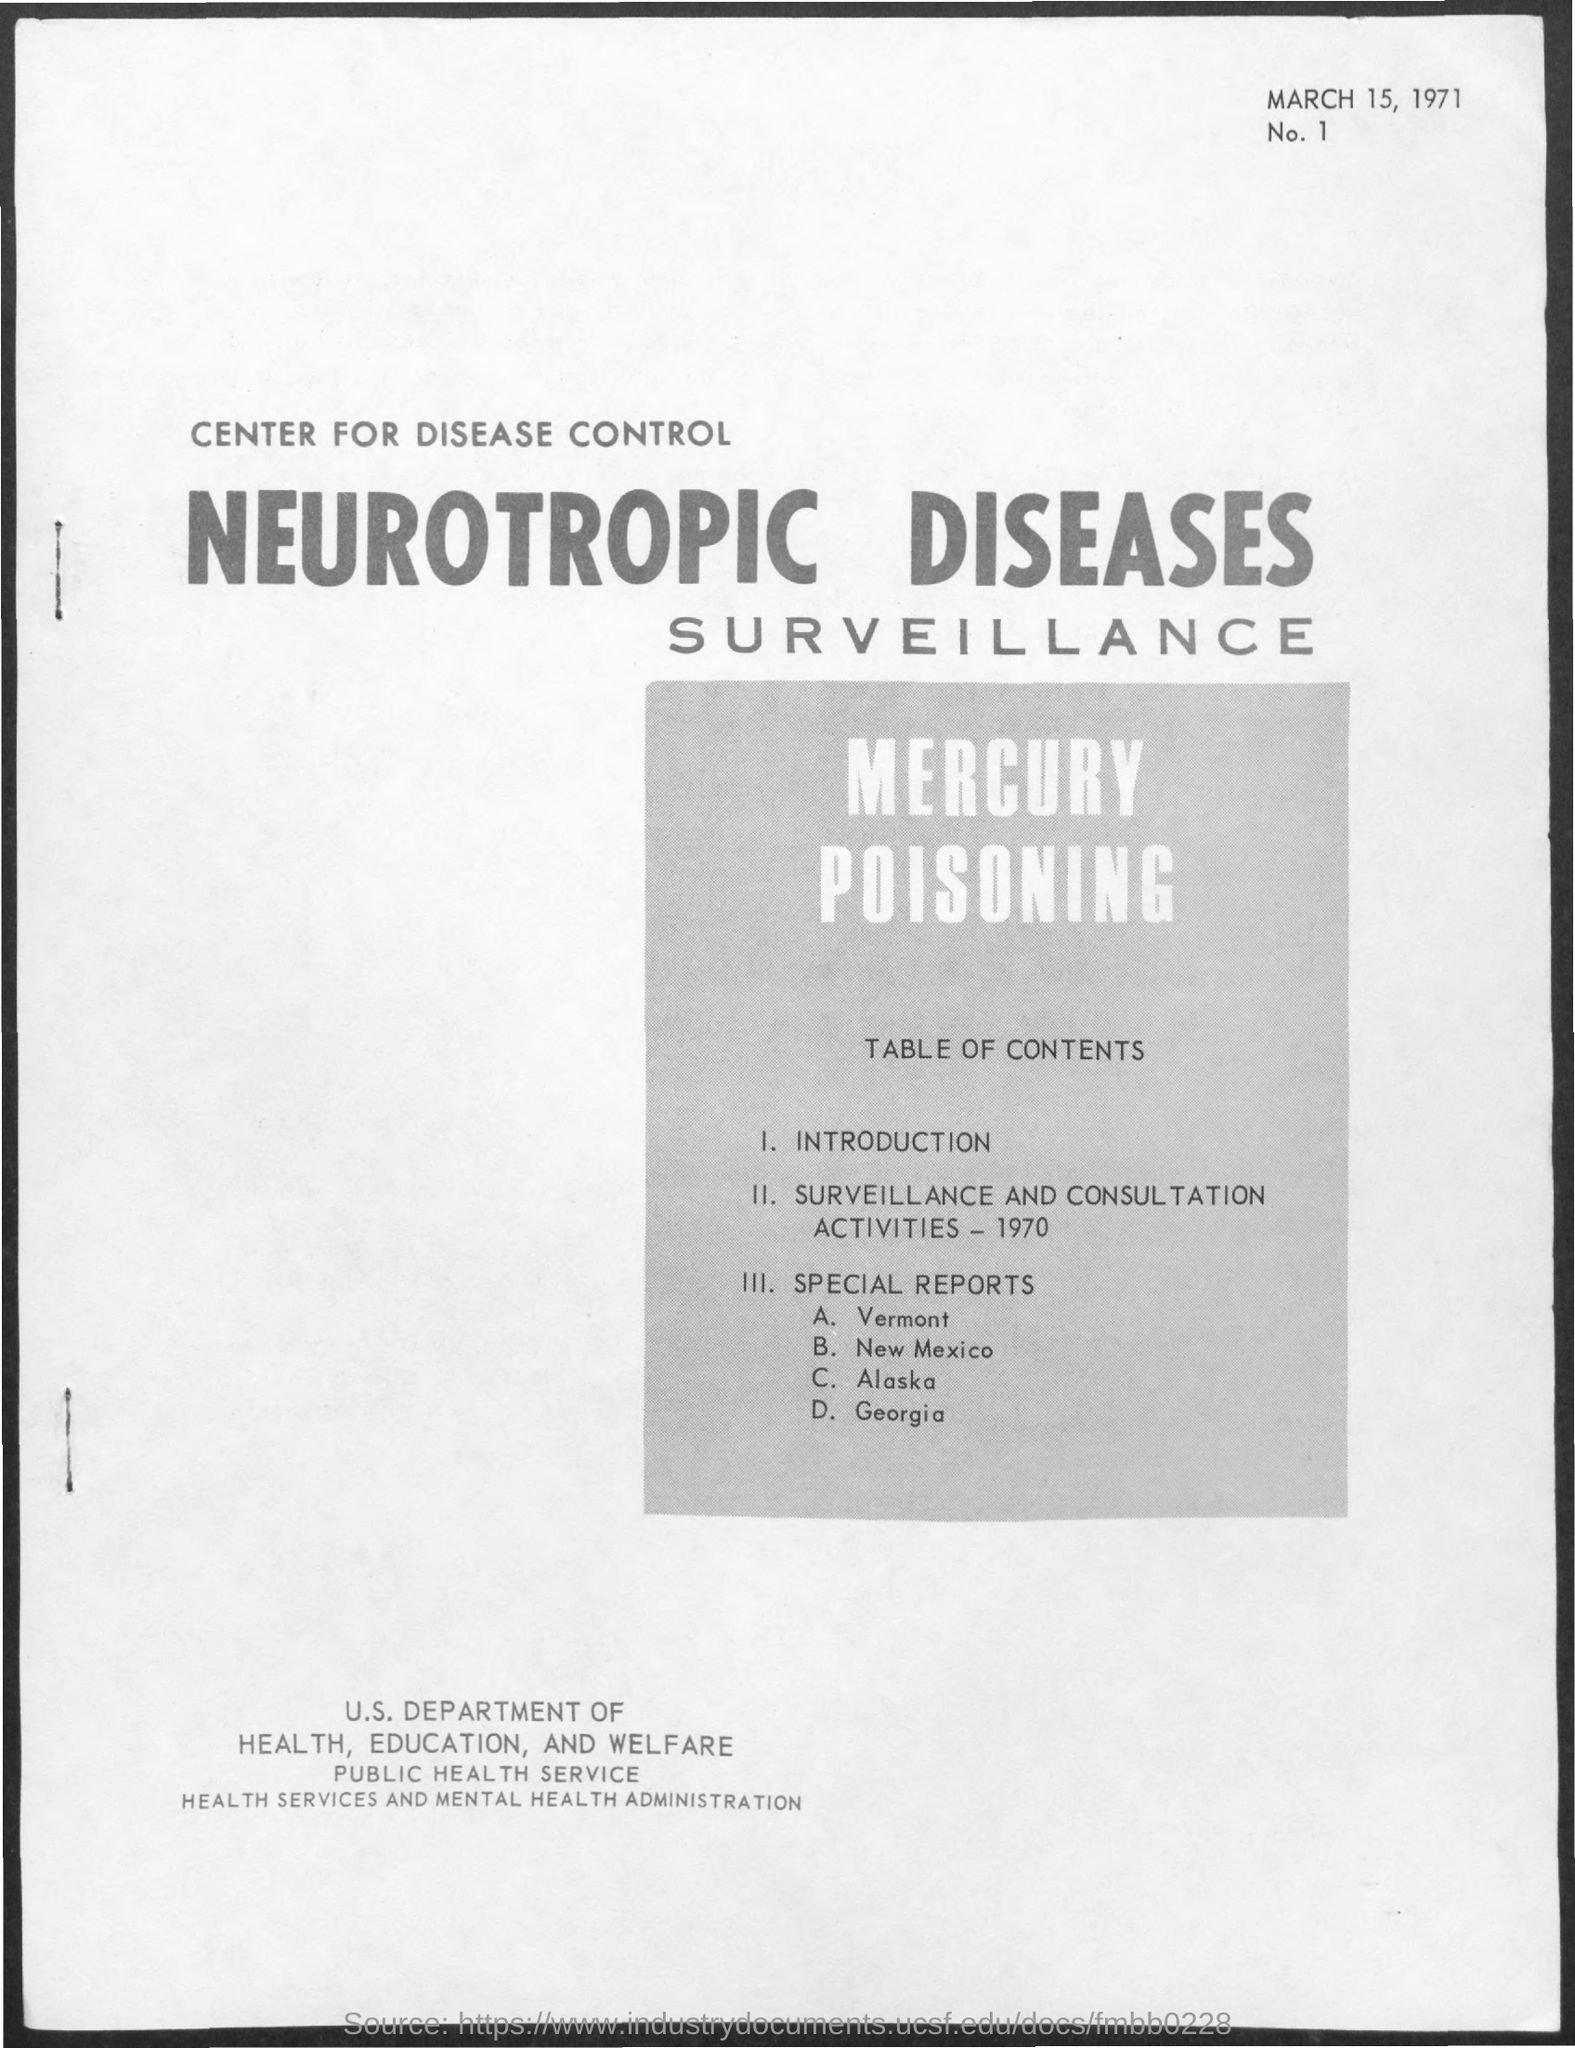Point out several critical features in this image. The date mentioned in the document is March 15, 1971. 